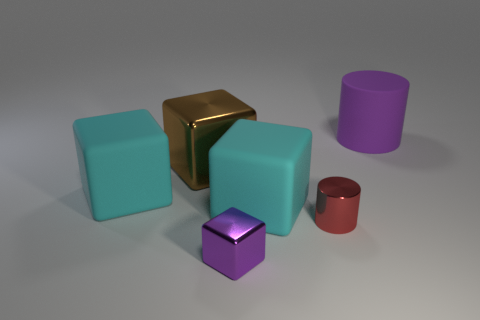The block that is the same color as the large cylinder is what size?
Provide a short and direct response. Small. There is a cylinder that is the same size as the brown metal block; what color is it?
Offer a terse response. Purple. There is a brown metal thing; is it the same shape as the tiny metallic thing behind the tiny metallic cube?
Ensure brevity in your answer.  No. How many objects are either large matte objects to the left of the red shiny thing or small blocks on the right side of the large brown cube?
Your response must be concise. 3. There is a big rubber thing that is the same color as the tiny metal cube; what shape is it?
Ensure brevity in your answer.  Cylinder. What is the shape of the cyan matte thing on the right side of the tiny metal block?
Give a very brief answer. Cube. Does the purple object in front of the big purple matte cylinder have the same shape as the tiny red metallic object?
Make the answer very short. No. How many things are objects that are behind the small metallic cylinder or red objects?
Keep it short and to the point. 5. The other small thing that is the same shape as the purple matte thing is what color?
Offer a very short reply. Red. Is there anything else that is the same color as the big matte cylinder?
Give a very brief answer. Yes. 